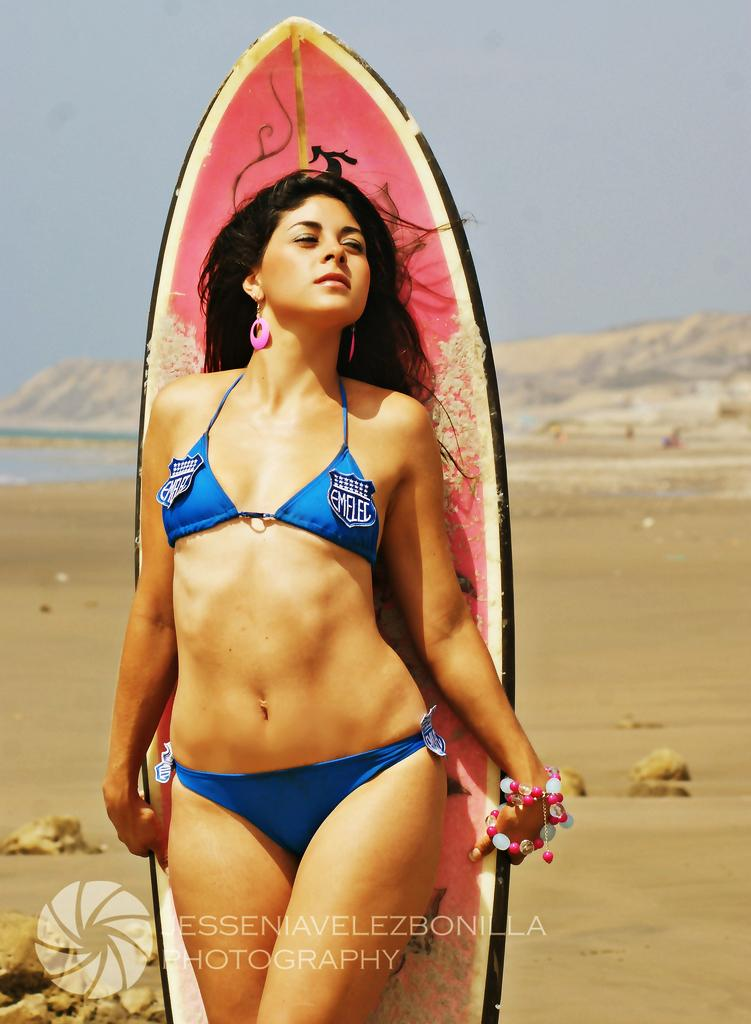Who is the main subject in the image? There is a woman in the image. What is the woman doing in the image? The woman is standing and holding a surfboard with her hands. What can be seen in the background of the image? There is a hill visible in the background of the image. What type of drug is the woman using in the image? There is no drug present in the image; the woman is holding a surfboard. What kind of pot is the woman standing next to in the image? There is no pot present in the image; the woman is holding a surfboard and standing near a hill. 